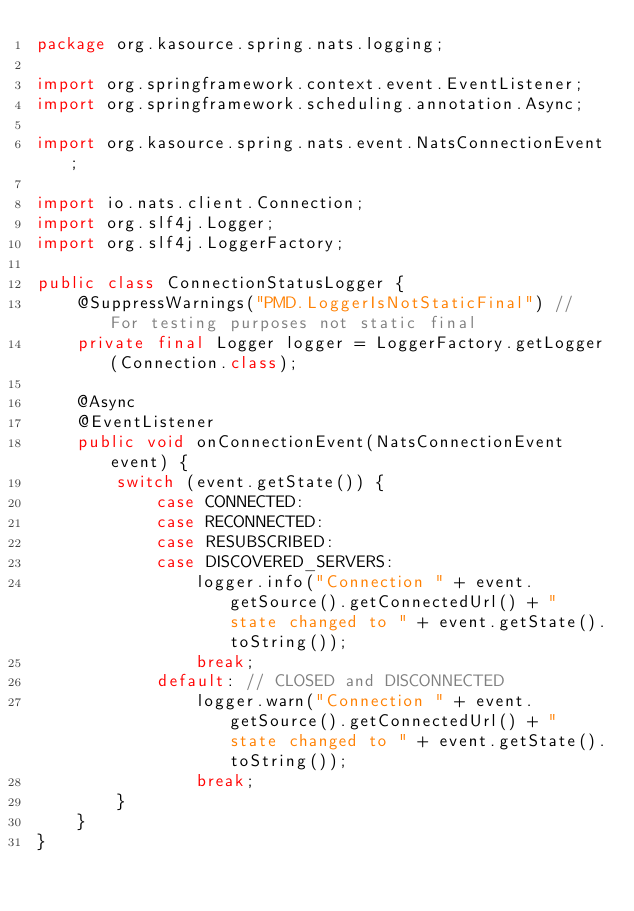<code> <loc_0><loc_0><loc_500><loc_500><_Java_>package org.kasource.spring.nats.logging;

import org.springframework.context.event.EventListener;
import org.springframework.scheduling.annotation.Async;

import org.kasource.spring.nats.event.NatsConnectionEvent;

import io.nats.client.Connection;
import org.slf4j.Logger;
import org.slf4j.LoggerFactory;

public class ConnectionStatusLogger {
    @SuppressWarnings("PMD.LoggerIsNotStaticFinal") // For testing purposes not static final
    private final Logger logger = LoggerFactory.getLogger(Connection.class);

    @Async
    @EventListener
    public void onConnectionEvent(NatsConnectionEvent event) {
        switch (event.getState()) {
            case CONNECTED:
            case RECONNECTED:
            case RESUBSCRIBED:
            case DISCOVERED_SERVERS:
                logger.info("Connection " + event.getSource().getConnectedUrl() + " state changed to " + event.getState().toString());
                break;
            default: // CLOSED and DISCONNECTED
                logger.warn("Connection " + event.getSource().getConnectedUrl() + " state changed to " + event.getState().toString());
                break;
        }
    }
}
</code> 